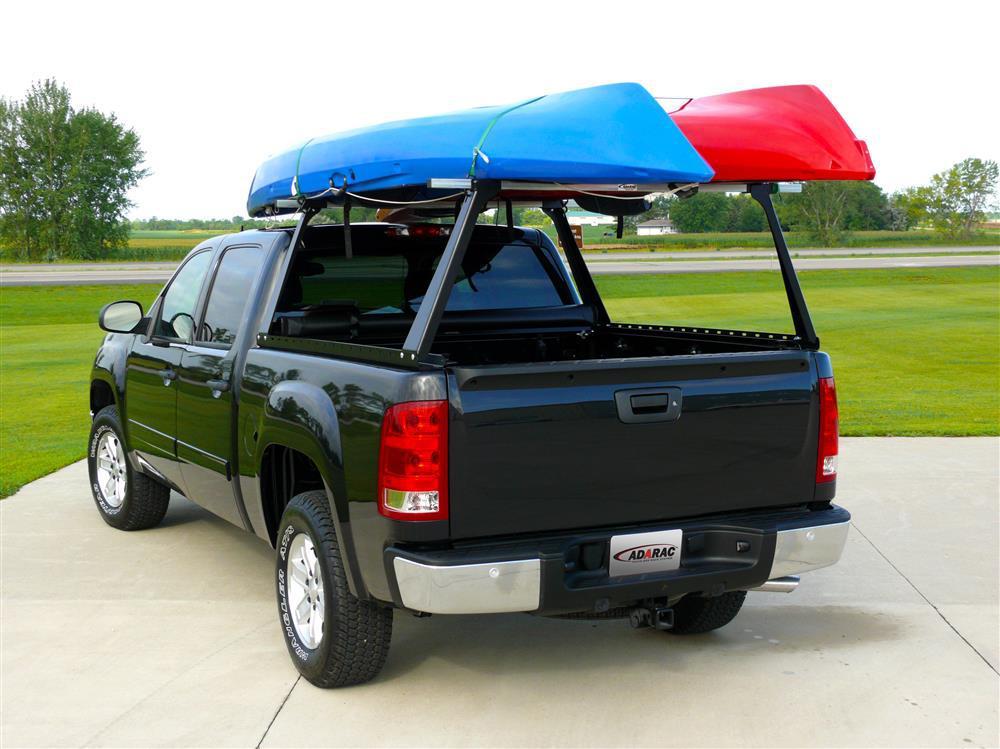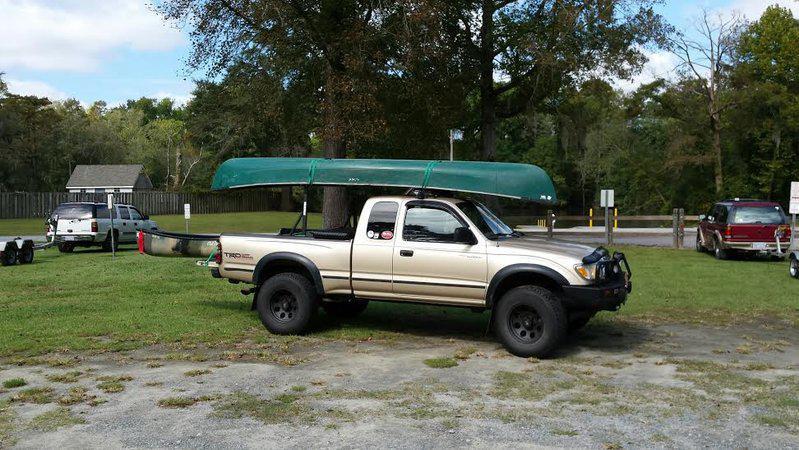The first image is the image on the left, the second image is the image on the right. For the images displayed, is the sentence "A dark green canoe is on top of an open-bed pickup truck." factually correct? Answer yes or no. Yes. 